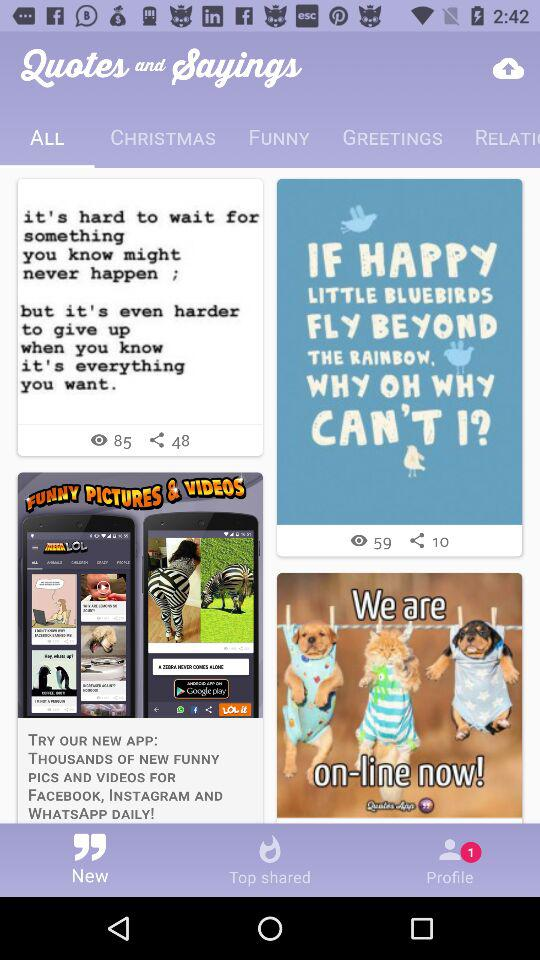What tab is selected? The selected tab is "ALL". 